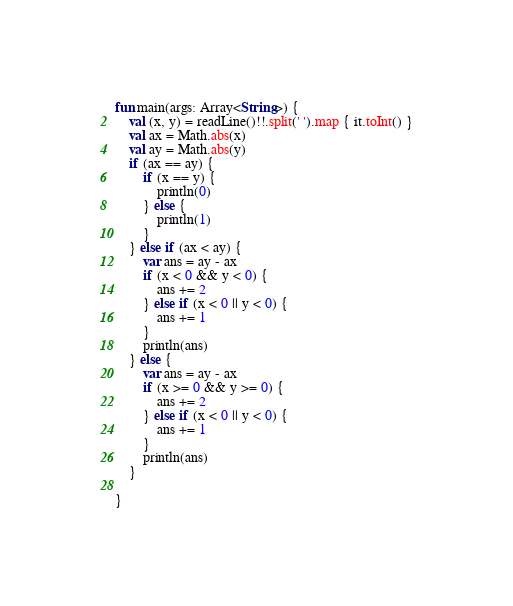Convert code to text. <code><loc_0><loc_0><loc_500><loc_500><_Kotlin_>fun main(args: Array<String>) {
    val (x, y) = readLine()!!.split(' ').map { it.toInt() }
    val ax = Math.abs(x)
    val ay = Math.abs(y)
    if (ax == ay) {
        if (x == y) {
            println(0)
        } else {
            println(1)
        }
    } else if (ax < ay) {
        var ans = ay - ax
        if (x < 0 && y < 0) {
            ans += 2
        } else if (x < 0 || y < 0) {
            ans += 1
        }
        println(ans)
    } else {
        var ans = ay - ax
        if (x >= 0 && y >= 0) {
            ans += 2
        } else if (x < 0 || y < 0) {
            ans += 1
        }
        println(ans)
    }

}
</code> 